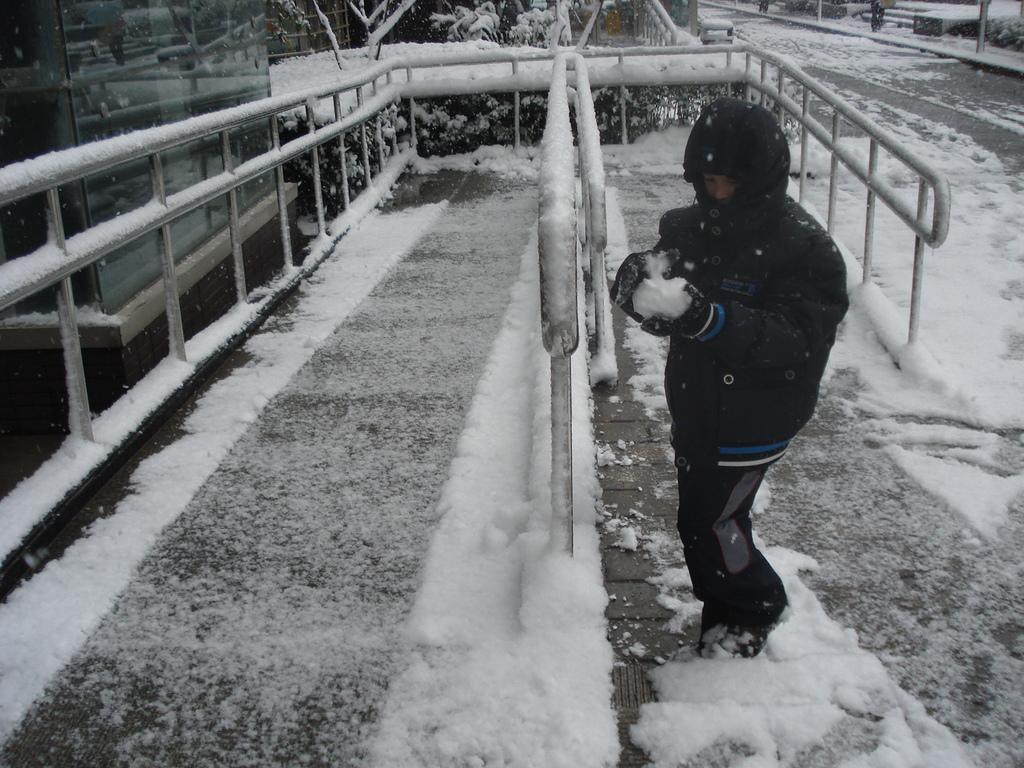Please provide a concise description of this image. In this image there is a person standing on the ground. There is snow on the ground. Behind the person there is a railing. To the left there is a glass wall. In the background there are trees. There is the snow on the trees. 